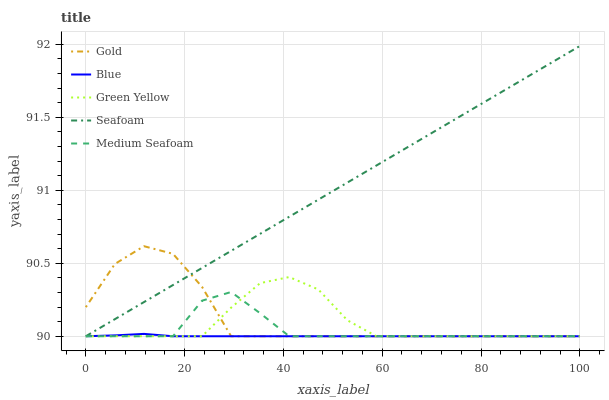Does Blue have the minimum area under the curve?
Answer yes or no. Yes. Does Seafoam have the maximum area under the curve?
Answer yes or no. Yes. Does Green Yellow have the minimum area under the curve?
Answer yes or no. No. Does Green Yellow have the maximum area under the curve?
Answer yes or no. No. Is Seafoam the smoothest?
Answer yes or no. Yes. Is Gold the roughest?
Answer yes or no. Yes. Is Green Yellow the smoothest?
Answer yes or no. No. Is Green Yellow the roughest?
Answer yes or no. No. Does Blue have the lowest value?
Answer yes or no. Yes. Does Seafoam have the highest value?
Answer yes or no. Yes. Does Green Yellow have the highest value?
Answer yes or no. No. Does Medium Seafoam intersect Blue?
Answer yes or no. Yes. Is Medium Seafoam less than Blue?
Answer yes or no. No. Is Medium Seafoam greater than Blue?
Answer yes or no. No. 